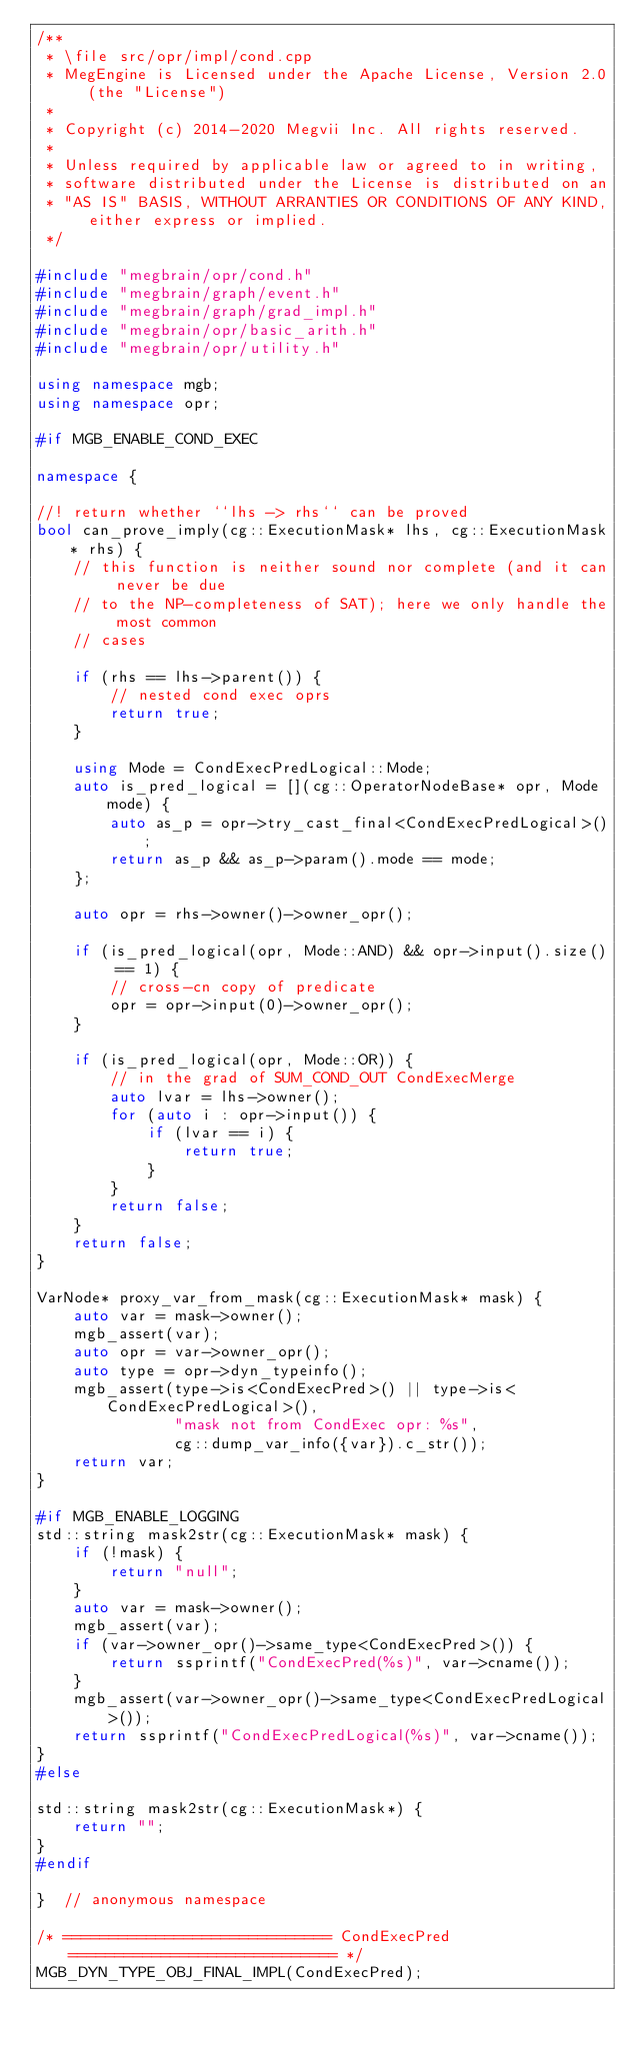<code> <loc_0><loc_0><loc_500><loc_500><_C++_>/**
 * \file src/opr/impl/cond.cpp
 * MegEngine is Licensed under the Apache License, Version 2.0 (the "License")
 *
 * Copyright (c) 2014-2020 Megvii Inc. All rights reserved.
 *
 * Unless required by applicable law or agreed to in writing,
 * software distributed under the License is distributed on an
 * "AS IS" BASIS, WITHOUT ARRANTIES OR CONDITIONS OF ANY KIND, either express or implied.
 */

#include "megbrain/opr/cond.h"
#include "megbrain/graph/event.h"
#include "megbrain/graph/grad_impl.h"
#include "megbrain/opr/basic_arith.h"
#include "megbrain/opr/utility.h"

using namespace mgb;
using namespace opr;

#if MGB_ENABLE_COND_EXEC

namespace {

//! return whether ``lhs -> rhs`` can be proved
bool can_prove_imply(cg::ExecutionMask* lhs, cg::ExecutionMask* rhs) {
    // this function is neither sound nor complete (and it can never be due
    // to the NP-completeness of SAT); here we only handle the most common
    // cases

    if (rhs == lhs->parent()) {
        // nested cond exec oprs
        return true;
    }

    using Mode = CondExecPredLogical::Mode;
    auto is_pred_logical = [](cg::OperatorNodeBase* opr, Mode mode) {
        auto as_p = opr->try_cast_final<CondExecPredLogical>();
        return as_p && as_p->param().mode == mode;
    };

    auto opr = rhs->owner()->owner_opr();

    if (is_pred_logical(opr, Mode::AND) && opr->input().size() == 1) {
        // cross-cn copy of predicate
        opr = opr->input(0)->owner_opr();
    }

    if (is_pred_logical(opr, Mode::OR)) {
        // in the grad of SUM_COND_OUT CondExecMerge
        auto lvar = lhs->owner();
        for (auto i : opr->input()) {
            if (lvar == i) {
                return true;
            }
        }
        return false;
    }
    return false;
}

VarNode* proxy_var_from_mask(cg::ExecutionMask* mask) {
    auto var = mask->owner();
    mgb_assert(var);
    auto opr = var->owner_opr();
    auto type = opr->dyn_typeinfo();
    mgb_assert(type->is<CondExecPred>() || type->is<CondExecPredLogical>(),
               "mask not from CondExec opr: %s",
               cg::dump_var_info({var}).c_str());
    return var;
}

#if MGB_ENABLE_LOGGING
std::string mask2str(cg::ExecutionMask* mask) {
    if (!mask) {
        return "null";
    }
    auto var = mask->owner();
    mgb_assert(var);
    if (var->owner_opr()->same_type<CondExecPred>()) {
        return ssprintf("CondExecPred(%s)", var->cname());
    }
    mgb_assert(var->owner_opr()->same_type<CondExecPredLogical>());
    return ssprintf("CondExecPredLogical(%s)", var->cname());
}
#else

std::string mask2str(cg::ExecutionMask*) {
    return "";
}
#endif

}  // anonymous namespace

/* ============================= CondExecPred ============================= */
MGB_DYN_TYPE_OBJ_FINAL_IMPL(CondExecPred);
</code> 